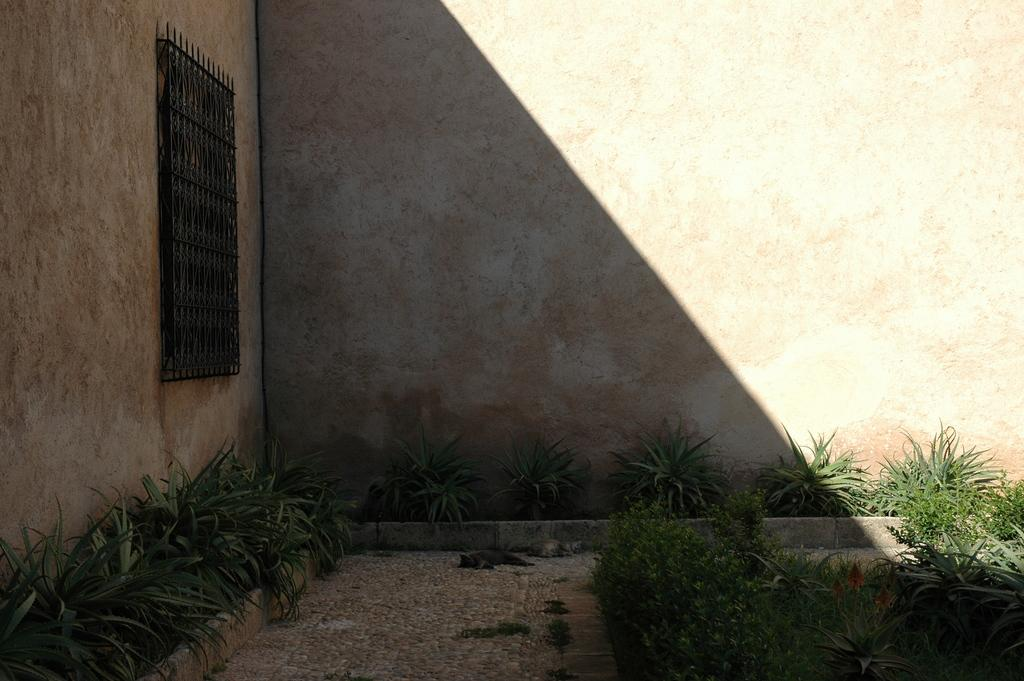What type of structure is visible in the image? The image contains walls of a house. What can be seen growing in the image? There are many plants in the image. Is there a path for people to walk on in the image? Yes, there is a walkway in the image. What feature allows light and air into the house in the image? There is a window in the image. Can you describe a metallic object present in the image? There is a metallic object in the image. What role does the sister play in the image? There is no mention of a sister in the image, so it is not possible to determine her role. 